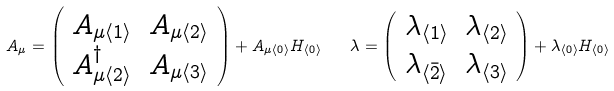Convert formula to latex. <formula><loc_0><loc_0><loc_500><loc_500>A _ { \mu } = \left ( \begin{array} { c c } { { A _ { \mu \langle 1 \rangle } } } & { { A _ { \mu \langle 2 \rangle } } } \\ { { A _ { \mu \langle 2 \rangle } ^ { \dagger } } } & { { A _ { \mu \langle 3 \rangle } } } \end{array} \right ) + A _ { \mu \langle 0 \rangle } H _ { \langle 0 \rangle } \quad \lambda = \left ( \begin{array} { c c } { { \lambda _ { \langle 1 \rangle } } } & { { \lambda _ { \langle 2 \rangle } } } \\ { { \lambda _ { \langle \bar { 2 } \rangle } } } & { { \lambda _ { \langle 3 \rangle } } } \end{array} \right ) + \lambda _ { \langle 0 \rangle } H _ { \langle 0 \rangle }</formula> 